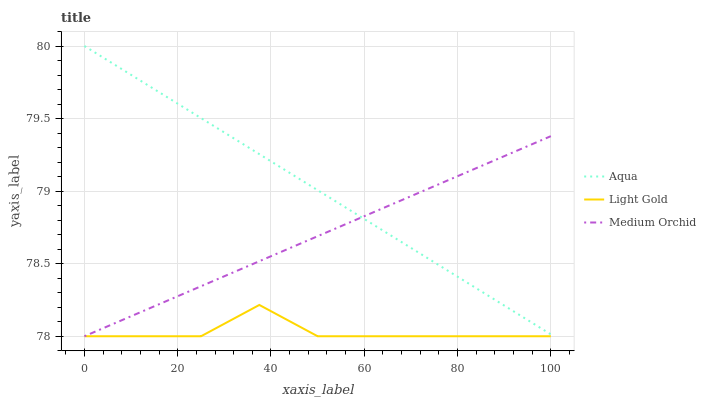Does Medium Orchid have the minimum area under the curve?
Answer yes or no. No. Does Medium Orchid have the maximum area under the curve?
Answer yes or no. No. Is Medium Orchid the smoothest?
Answer yes or no. No. Is Medium Orchid the roughest?
Answer yes or no. No. Does Aqua have the lowest value?
Answer yes or no. No. Does Medium Orchid have the highest value?
Answer yes or no. No. Is Light Gold less than Aqua?
Answer yes or no. Yes. Is Aqua greater than Light Gold?
Answer yes or no. Yes. Does Light Gold intersect Aqua?
Answer yes or no. No. 